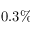<formula> <loc_0><loc_0><loc_500><loc_500>0 . 3 \%</formula> 